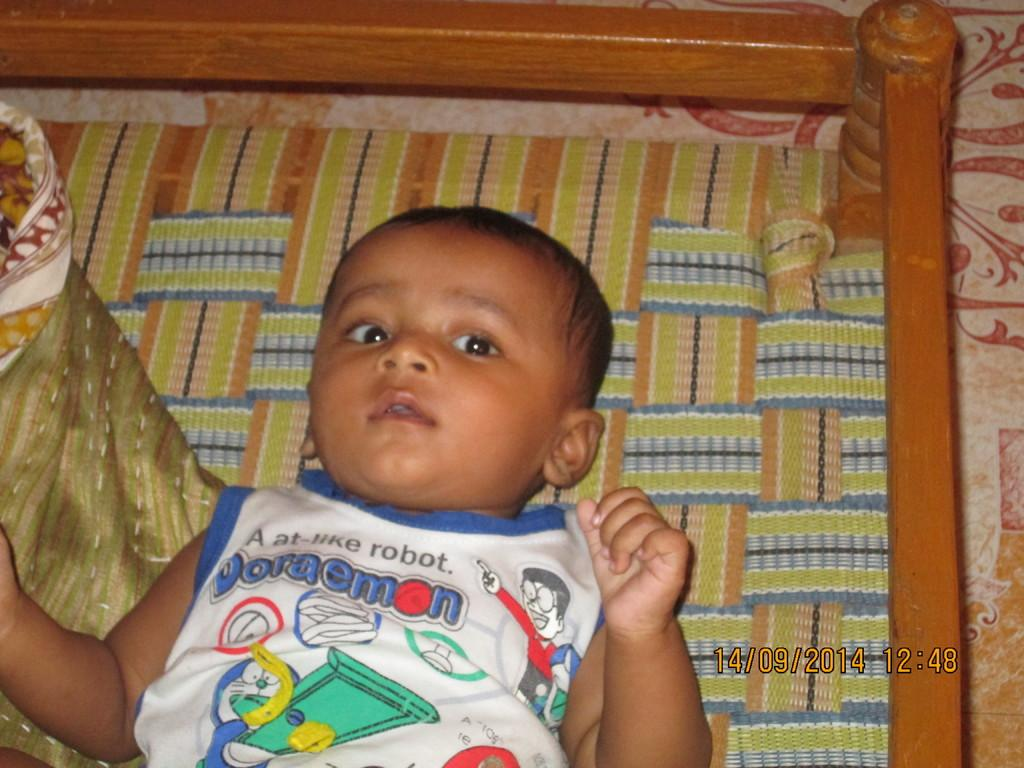What is the main subject of the picture? The main subject of the picture is a baby. Where is the baby located in the image? The baby is on a cot in the center of the picture. What can be seen on the left side of the image? There is a blanket on the left side of the image. What is visible on the right side of the image? The right side of the image shows the floor. What is the purpose of the war in the image? There is no war depicted in the image; it features a baby on a cot with a blanket and the floor visible. 